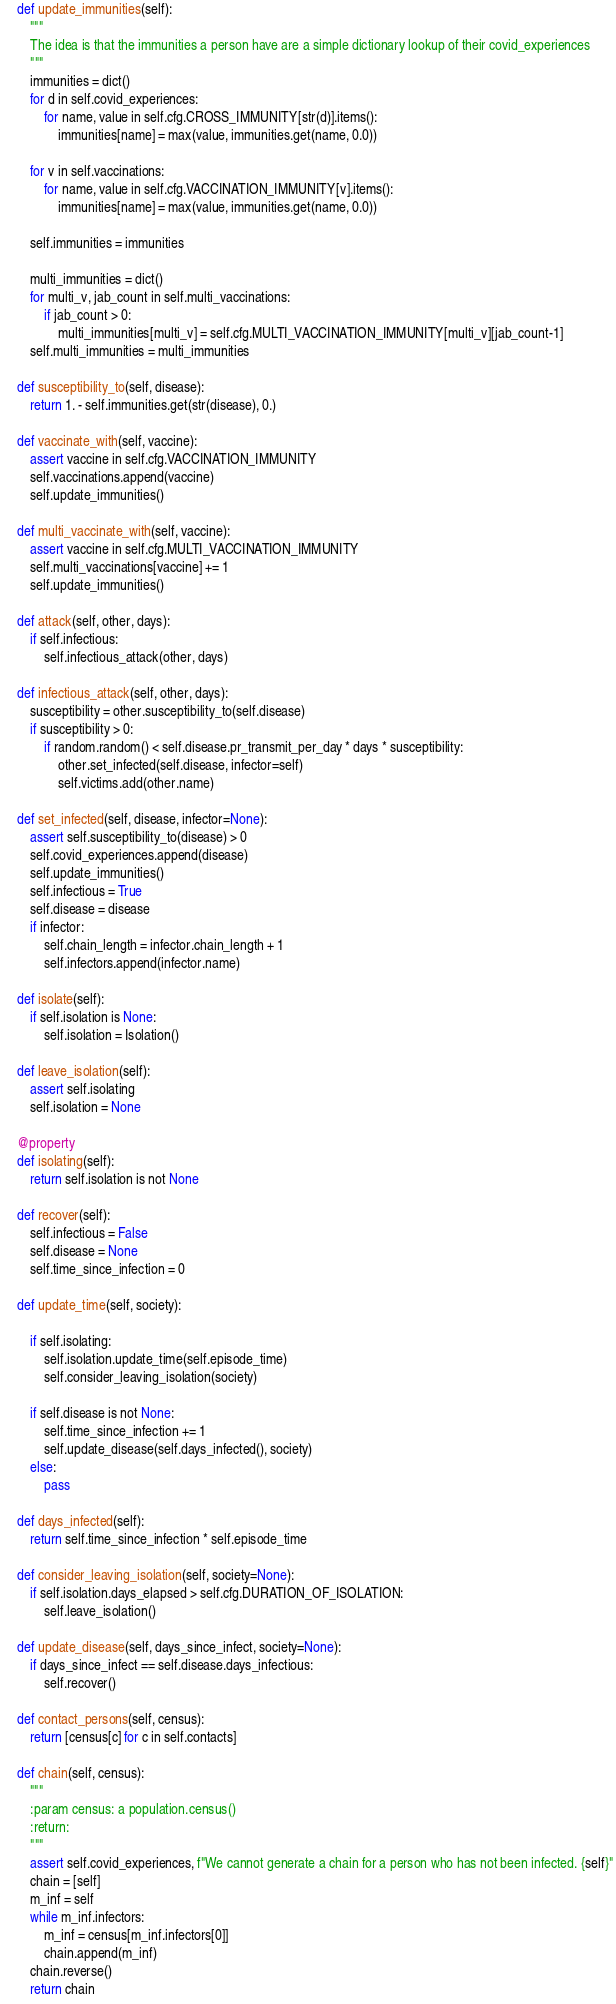<code> <loc_0><loc_0><loc_500><loc_500><_Python_>    def update_immunities(self):
        """
        The idea is that the immunities a person have are a simple dictionary lookup of their covid_experiences
        """
        immunities = dict()
        for d in self.covid_experiences:
            for name, value in self.cfg.CROSS_IMMUNITY[str(d)].items():
                immunities[name] = max(value, immunities.get(name, 0.0))

        for v in self.vaccinations:
            for name, value in self.cfg.VACCINATION_IMMUNITY[v].items():
                immunities[name] = max(value, immunities.get(name, 0.0))

        self.immunities = immunities

        multi_immunities = dict()
        for multi_v, jab_count in self.multi_vaccinations:
            if jab_count > 0:
                multi_immunities[multi_v] = self.cfg.MULTI_VACCINATION_IMMUNITY[multi_v][jab_count-1]
        self.multi_immunities = multi_immunities

    def susceptibility_to(self, disease):
        return 1. - self.immunities.get(str(disease), 0.)

    def vaccinate_with(self, vaccine):
        assert vaccine in self.cfg.VACCINATION_IMMUNITY
        self.vaccinations.append(vaccine)
        self.update_immunities()

    def multi_vaccinate_with(self, vaccine):
        assert vaccine in self.cfg.MULTI_VACCINATION_IMMUNITY
        self.multi_vaccinations[vaccine] += 1
        self.update_immunities()

    def attack(self, other, days):
        if self.infectious:
            self.infectious_attack(other, days)

    def infectious_attack(self, other, days):
        susceptibility = other.susceptibility_to(self.disease)
        if susceptibility > 0:
            if random.random() < self.disease.pr_transmit_per_day * days * susceptibility:
                other.set_infected(self.disease, infector=self)
                self.victims.add(other.name)

    def set_infected(self, disease, infector=None):
        assert self.susceptibility_to(disease) > 0
        self.covid_experiences.append(disease)
        self.update_immunities()
        self.infectious = True
        self.disease = disease
        if infector:
            self.chain_length = infector.chain_length + 1
            self.infectors.append(infector.name)

    def isolate(self):
        if self.isolation is None:
            self.isolation = Isolation()

    def leave_isolation(self):
        assert self.isolating
        self.isolation = None

    @property
    def isolating(self):
        return self.isolation is not None

    def recover(self):
        self.infectious = False
        self.disease = None
        self.time_since_infection = 0

    def update_time(self, society):

        if self.isolating:
            self.isolation.update_time(self.episode_time)
            self.consider_leaving_isolation(society)

        if self.disease is not None:
            self.time_since_infection += 1
            self.update_disease(self.days_infected(), society)
        else:
            pass

    def days_infected(self):
        return self.time_since_infection * self.episode_time

    def consider_leaving_isolation(self, society=None):
        if self.isolation.days_elapsed > self.cfg.DURATION_OF_ISOLATION:
            self.leave_isolation()

    def update_disease(self, days_since_infect, society=None):
        if days_since_infect == self.disease.days_infectious:
            self.recover()

    def contact_persons(self, census):
        return [census[c] for c in self.contacts]

    def chain(self, census):
        """
        :param census: a population.census()
        :return:
        """
        assert self.covid_experiences, f"We cannot generate a chain for a person who has not been infected. {self}"
        chain = [self]
        m_inf = self
        while m_inf.infectors:
            m_inf = census[m_inf.infectors[0]]
            chain.append(m_inf)
        chain.reverse()
        return chain
</code> 